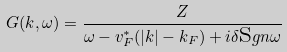Convert formula to latex. <formula><loc_0><loc_0><loc_500><loc_500>G ( k , \omega ) = \frac { Z } { \omega - v ^ { * } _ { F } ( | k | - k _ { F } ) + i \delta { \text  sgn} \omega}</formula> 